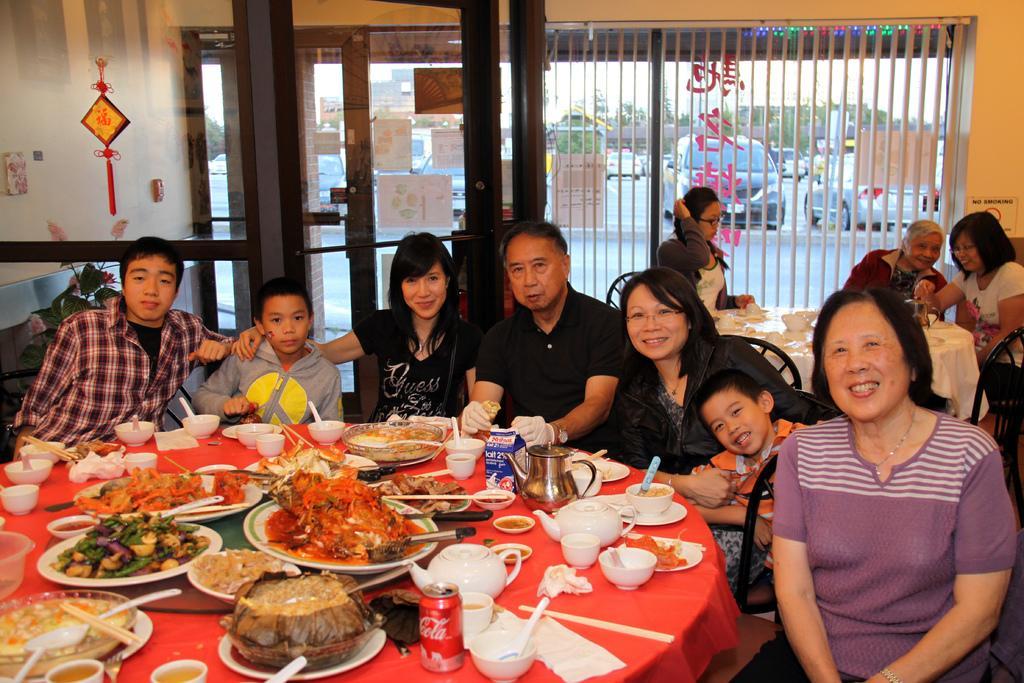How would you summarize this image in a sentence or two? In this picture there are people sitting on chairs and we can see plates, bowls, food, spoons, sticks, tin, kettles, jug and objects on tables. We can see glass, posters and wall, through glass we can see vehicles on the road, trees and sky. 